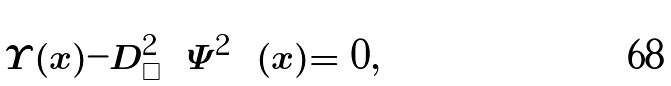<formula> <loc_0><loc_0><loc_500><loc_500>\Upsilon ( x ) - D ^ { 2 } _ { \Box } \left ( \Psi ^ { 2 } \right ) ( x ) = 0 ,</formula> 